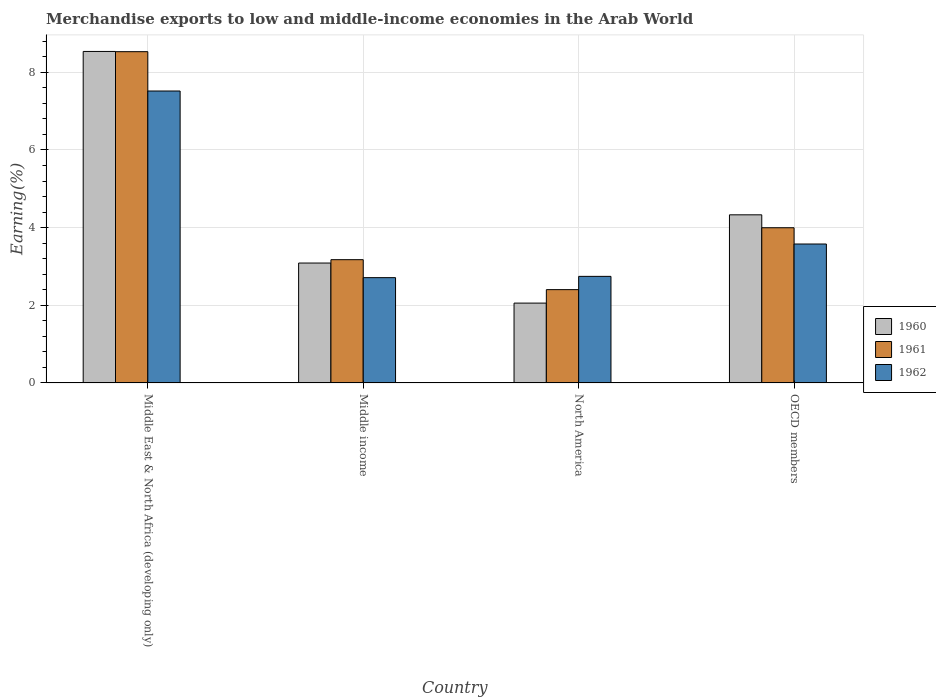How many different coloured bars are there?
Give a very brief answer. 3. Are the number of bars per tick equal to the number of legend labels?
Ensure brevity in your answer.  Yes. Are the number of bars on each tick of the X-axis equal?
Your response must be concise. Yes. How many bars are there on the 2nd tick from the right?
Ensure brevity in your answer.  3. What is the label of the 3rd group of bars from the left?
Offer a very short reply. North America. In how many cases, is the number of bars for a given country not equal to the number of legend labels?
Provide a succinct answer. 0. What is the percentage of amount earned from merchandise exports in 1961 in OECD members?
Make the answer very short. 4. Across all countries, what is the maximum percentage of amount earned from merchandise exports in 1962?
Ensure brevity in your answer.  7.52. Across all countries, what is the minimum percentage of amount earned from merchandise exports in 1961?
Keep it short and to the point. 2.4. In which country was the percentage of amount earned from merchandise exports in 1962 maximum?
Keep it short and to the point. Middle East & North Africa (developing only). In which country was the percentage of amount earned from merchandise exports in 1961 minimum?
Offer a very short reply. North America. What is the total percentage of amount earned from merchandise exports in 1962 in the graph?
Provide a short and direct response. 16.55. What is the difference between the percentage of amount earned from merchandise exports in 1962 in North America and that in OECD members?
Provide a short and direct response. -0.83. What is the difference between the percentage of amount earned from merchandise exports in 1960 in North America and the percentage of amount earned from merchandise exports in 1962 in Middle East & North Africa (developing only)?
Provide a short and direct response. -5.46. What is the average percentage of amount earned from merchandise exports in 1961 per country?
Provide a succinct answer. 4.53. What is the difference between the percentage of amount earned from merchandise exports of/in 1962 and percentage of amount earned from merchandise exports of/in 1960 in Middle East & North Africa (developing only)?
Your answer should be very brief. -1.02. What is the ratio of the percentage of amount earned from merchandise exports in 1962 in Middle East & North Africa (developing only) to that in Middle income?
Make the answer very short. 2.77. Is the percentage of amount earned from merchandise exports in 1960 in Middle East & North Africa (developing only) less than that in OECD members?
Your answer should be very brief. No. Is the difference between the percentage of amount earned from merchandise exports in 1962 in Middle income and North America greater than the difference between the percentage of amount earned from merchandise exports in 1960 in Middle income and North America?
Give a very brief answer. No. What is the difference between the highest and the second highest percentage of amount earned from merchandise exports in 1961?
Offer a very short reply. 4.53. What is the difference between the highest and the lowest percentage of amount earned from merchandise exports in 1962?
Keep it short and to the point. 4.81. In how many countries, is the percentage of amount earned from merchandise exports in 1962 greater than the average percentage of amount earned from merchandise exports in 1962 taken over all countries?
Ensure brevity in your answer.  1. Is the sum of the percentage of amount earned from merchandise exports in 1961 in Middle East & North Africa (developing only) and OECD members greater than the maximum percentage of amount earned from merchandise exports in 1962 across all countries?
Provide a succinct answer. Yes. What does the 1st bar from the left in Middle East & North Africa (developing only) represents?
Your response must be concise. 1960. Is it the case that in every country, the sum of the percentage of amount earned from merchandise exports in 1961 and percentage of amount earned from merchandise exports in 1962 is greater than the percentage of amount earned from merchandise exports in 1960?
Ensure brevity in your answer.  Yes. How many bars are there?
Your answer should be compact. 12. What is the difference between two consecutive major ticks on the Y-axis?
Provide a succinct answer. 2. What is the title of the graph?
Offer a terse response. Merchandise exports to low and middle-income economies in the Arab World. Does "1962" appear as one of the legend labels in the graph?
Offer a very short reply. Yes. What is the label or title of the Y-axis?
Make the answer very short. Earning(%). What is the Earning(%) of 1960 in Middle East & North Africa (developing only)?
Your answer should be very brief. 8.54. What is the Earning(%) in 1961 in Middle East & North Africa (developing only)?
Keep it short and to the point. 8.53. What is the Earning(%) in 1962 in Middle East & North Africa (developing only)?
Provide a short and direct response. 7.52. What is the Earning(%) in 1960 in Middle income?
Make the answer very short. 3.09. What is the Earning(%) in 1961 in Middle income?
Make the answer very short. 3.17. What is the Earning(%) of 1962 in Middle income?
Give a very brief answer. 2.71. What is the Earning(%) of 1960 in North America?
Make the answer very short. 2.06. What is the Earning(%) of 1961 in North America?
Offer a terse response. 2.4. What is the Earning(%) of 1962 in North America?
Your response must be concise. 2.74. What is the Earning(%) of 1960 in OECD members?
Make the answer very short. 4.33. What is the Earning(%) in 1961 in OECD members?
Make the answer very short. 4. What is the Earning(%) of 1962 in OECD members?
Provide a short and direct response. 3.58. Across all countries, what is the maximum Earning(%) of 1960?
Provide a short and direct response. 8.54. Across all countries, what is the maximum Earning(%) in 1961?
Keep it short and to the point. 8.53. Across all countries, what is the maximum Earning(%) in 1962?
Ensure brevity in your answer.  7.52. Across all countries, what is the minimum Earning(%) of 1960?
Provide a short and direct response. 2.06. Across all countries, what is the minimum Earning(%) of 1961?
Make the answer very short. 2.4. Across all countries, what is the minimum Earning(%) of 1962?
Offer a very short reply. 2.71. What is the total Earning(%) of 1960 in the graph?
Ensure brevity in your answer.  18.01. What is the total Earning(%) of 1961 in the graph?
Your answer should be compact. 18.11. What is the total Earning(%) of 1962 in the graph?
Keep it short and to the point. 16.55. What is the difference between the Earning(%) of 1960 in Middle East & North Africa (developing only) and that in Middle income?
Provide a short and direct response. 5.45. What is the difference between the Earning(%) of 1961 in Middle East & North Africa (developing only) and that in Middle income?
Your answer should be compact. 5.36. What is the difference between the Earning(%) of 1962 in Middle East & North Africa (developing only) and that in Middle income?
Ensure brevity in your answer.  4.81. What is the difference between the Earning(%) of 1960 in Middle East & North Africa (developing only) and that in North America?
Give a very brief answer. 6.48. What is the difference between the Earning(%) in 1961 in Middle East & North Africa (developing only) and that in North America?
Keep it short and to the point. 6.13. What is the difference between the Earning(%) of 1962 in Middle East & North Africa (developing only) and that in North America?
Offer a terse response. 4.77. What is the difference between the Earning(%) in 1960 in Middle East & North Africa (developing only) and that in OECD members?
Give a very brief answer. 4.21. What is the difference between the Earning(%) in 1961 in Middle East & North Africa (developing only) and that in OECD members?
Offer a terse response. 4.53. What is the difference between the Earning(%) in 1962 in Middle East & North Africa (developing only) and that in OECD members?
Your answer should be very brief. 3.94. What is the difference between the Earning(%) of 1960 in Middle income and that in North America?
Your response must be concise. 1.03. What is the difference between the Earning(%) of 1961 in Middle income and that in North America?
Keep it short and to the point. 0.77. What is the difference between the Earning(%) of 1962 in Middle income and that in North America?
Offer a very short reply. -0.03. What is the difference between the Earning(%) in 1960 in Middle income and that in OECD members?
Keep it short and to the point. -1.24. What is the difference between the Earning(%) in 1961 in Middle income and that in OECD members?
Offer a very short reply. -0.82. What is the difference between the Earning(%) in 1962 in Middle income and that in OECD members?
Offer a terse response. -0.87. What is the difference between the Earning(%) in 1960 in North America and that in OECD members?
Your answer should be very brief. -2.27. What is the difference between the Earning(%) of 1961 in North America and that in OECD members?
Give a very brief answer. -1.59. What is the difference between the Earning(%) in 1962 in North America and that in OECD members?
Give a very brief answer. -0.83. What is the difference between the Earning(%) in 1960 in Middle East & North Africa (developing only) and the Earning(%) in 1961 in Middle income?
Your response must be concise. 5.36. What is the difference between the Earning(%) in 1960 in Middle East & North Africa (developing only) and the Earning(%) in 1962 in Middle income?
Make the answer very short. 5.83. What is the difference between the Earning(%) of 1961 in Middle East & North Africa (developing only) and the Earning(%) of 1962 in Middle income?
Your answer should be very brief. 5.82. What is the difference between the Earning(%) in 1960 in Middle East & North Africa (developing only) and the Earning(%) in 1961 in North America?
Your response must be concise. 6.13. What is the difference between the Earning(%) of 1960 in Middle East & North Africa (developing only) and the Earning(%) of 1962 in North America?
Your answer should be compact. 5.79. What is the difference between the Earning(%) of 1961 in Middle East & North Africa (developing only) and the Earning(%) of 1962 in North America?
Make the answer very short. 5.79. What is the difference between the Earning(%) in 1960 in Middle East & North Africa (developing only) and the Earning(%) in 1961 in OECD members?
Provide a short and direct response. 4.54. What is the difference between the Earning(%) of 1960 in Middle East & North Africa (developing only) and the Earning(%) of 1962 in OECD members?
Your response must be concise. 4.96. What is the difference between the Earning(%) of 1961 in Middle East & North Africa (developing only) and the Earning(%) of 1962 in OECD members?
Give a very brief answer. 4.95. What is the difference between the Earning(%) in 1960 in Middle income and the Earning(%) in 1961 in North America?
Offer a terse response. 0.68. What is the difference between the Earning(%) of 1960 in Middle income and the Earning(%) of 1962 in North America?
Provide a short and direct response. 0.34. What is the difference between the Earning(%) in 1961 in Middle income and the Earning(%) in 1962 in North America?
Your answer should be very brief. 0.43. What is the difference between the Earning(%) of 1960 in Middle income and the Earning(%) of 1961 in OECD members?
Provide a short and direct response. -0.91. What is the difference between the Earning(%) of 1960 in Middle income and the Earning(%) of 1962 in OECD members?
Provide a short and direct response. -0.49. What is the difference between the Earning(%) of 1961 in Middle income and the Earning(%) of 1962 in OECD members?
Keep it short and to the point. -0.4. What is the difference between the Earning(%) of 1960 in North America and the Earning(%) of 1961 in OECD members?
Provide a succinct answer. -1.94. What is the difference between the Earning(%) in 1960 in North America and the Earning(%) in 1962 in OECD members?
Give a very brief answer. -1.52. What is the difference between the Earning(%) of 1961 in North America and the Earning(%) of 1962 in OECD members?
Give a very brief answer. -1.17. What is the average Earning(%) of 1960 per country?
Provide a short and direct response. 4.5. What is the average Earning(%) of 1961 per country?
Make the answer very short. 4.53. What is the average Earning(%) of 1962 per country?
Your answer should be very brief. 4.14. What is the difference between the Earning(%) of 1960 and Earning(%) of 1961 in Middle East & North Africa (developing only)?
Offer a terse response. 0.01. What is the difference between the Earning(%) in 1960 and Earning(%) in 1962 in Middle East & North Africa (developing only)?
Keep it short and to the point. 1.02. What is the difference between the Earning(%) in 1961 and Earning(%) in 1962 in Middle East & North Africa (developing only)?
Provide a succinct answer. 1.01. What is the difference between the Earning(%) of 1960 and Earning(%) of 1961 in Middle income?
Offer a terse response. -0.09. What is the difference between the Earning(%) of 1960 and Earning(%) of 1962 in Middle income?
Offer a very short reply. 0.38. What is the difference between the Earning(%) of 1961 and Earning(%) of 1962 in Middle income?
Give a very brief answer. 0.46. What is the difference between the Earning(%) in 1960 and Earning(%) in 1961 in North America?
Make the answer very short. -0.35. What is the difference between the Earning(%) in 1960 and Earning(%) in 1962 in North America?
Your response must be concise. -0.69. What is the difference between the Earning(%) in 1961 and Earning(%) in 1962 in North America?
Provide a succinct answer. -0.34. What is the difference between the Earning(%) in 1960 and Earning(%) in 1961 in OECD members?
Keep it short and to the point. 0.33. What is the difference between the Earning(%) of 1960 and Earning(%) of 1962 in OECD members?
Provide a succinct answer. 0.75. What is the difference between the Earning(%) in 1961 and Earning(%) in 1962 in OECD members?
Your answer should be very brief. 0.42. What is the ratio of the Earning(%) of 1960 in Middle East & North Africa (developing only) to that in Middle income?
Ensure brevity in your answer.  2.76. What is the ratio of the Earning(%) of 1961 in Middle East & North Africa (developing only) to that in Middle income?
Offer a terse response. 2.69. What is the ratio of the Earning(%) in 1962 in Middle East & North Africa (developing only) to that in Middle income?
Your answer should be compact. 2.77. What is the ratio of the Earning(%) of 1960 in Middle East & North Africa (developing only) to that in North America?
Your response must be concise. 4.15. What is the ratio of the Earning(%) of 1961 in Middle East & North Africa (developing only) to that in North America?
Your response must be concise. 3.55. What is the ratio of the Earning(%) in 1962 in Middle East & North Africa (developing only) to that in North America?
Offer a very short reply. 2.74. What is the ratio of the Earning(%) of 1960 in Middle East & North Africa (developing only) to that in OECD members?
Your answer should be compact. 1.97. What is the ratio of the Earning(%) of 1961 in Middle East & North Africa (developing only) to that in OECD members?
Keep it short and to the point. 2.13. What is the ratio of the Earning(%) of 1962 in Middle East & North Africa (developing only) to that in OECD members?
Your answer should be compact. 2.1. What is the ratio of the Earning(%) of 1960 in Middle income to that in North America?
Offer a very short reply. 1.5. What is the ratio of the Earning(%) of 1961 in Middle income to that in North America?
Make the answer very short. 1.32. What is the ratio of the Earning(%) of 1960 in Middle income to that in OECD members?
Your answer should be compact. 0.71. What is the ratio of the Earning(%) of 1961 in Middle income to that in OECD members?
Provide a succinct answer. 0.79. What is the ratio of the Earning(%) of 1962 in Middle income to that in OECD members?
Offer a terse response. 0.76. What is the ratio of the Earning(%) of 1960 in North America to that in OECD members?
Provide a short and direct response. 0.47. What is the ratio of the Earning(%) of 1961 in North America to that in OECD members?
Make the answer very short. 0.6. What is the ratio of the Earning(%) of 1962 in North America to that in OECD members?
Ensure brevity in your answer.  0.77. What is the difference between the highest and the second highest Earning(%) in 1960?
Offer a terse response. 4.21. What is the difference between the highest and the second highest Earning(%) of 1961?
Your answer should be very brief. 4.53. What is the difference between the highest and the second highest Earning(%) in 1962?
Your answer should be very brief. 3.94. What is the difference between the highest and the lowest Earning(%) of 1960?
Your answer should be very brief. 6.48. What is the difference between the highest and the lowest Earning(%) of 1961?
Give a very brief answer. 6.13. What is the difference between the highest and the lowest Earning(%) in 1962?
Keep it short and to the point. 4.81. 